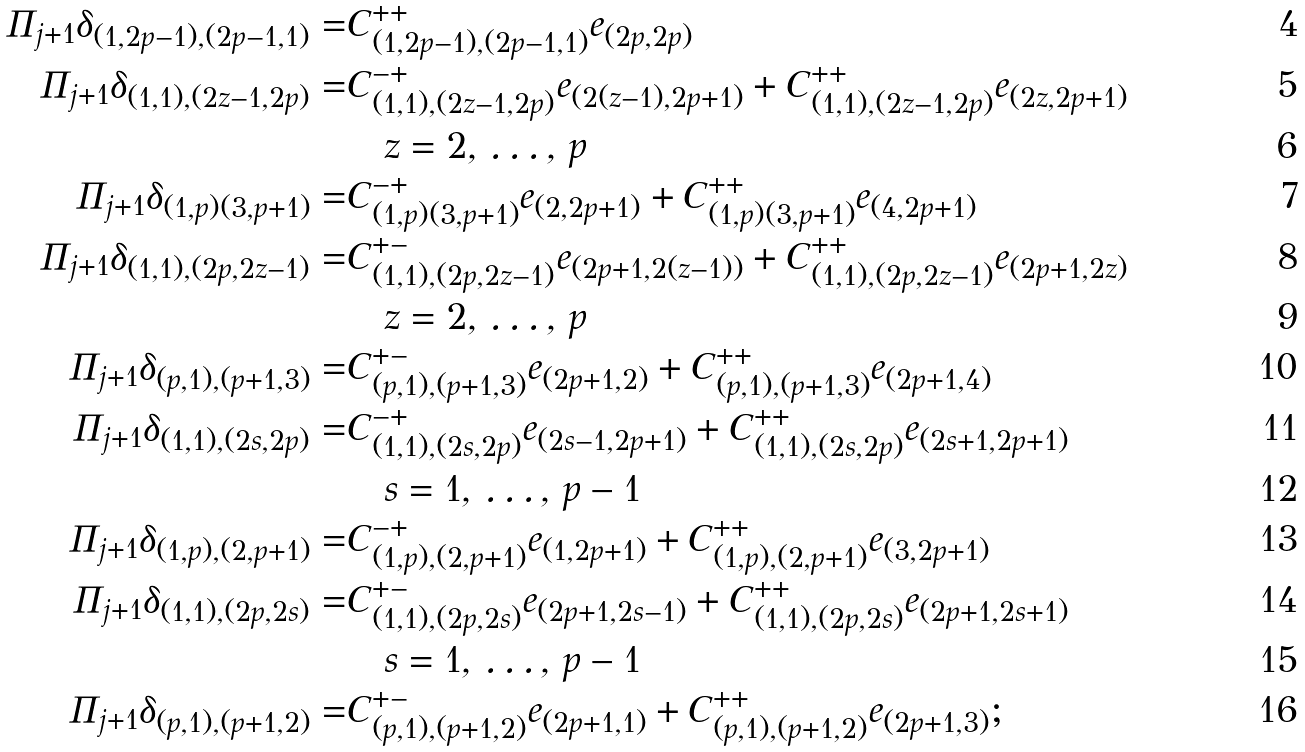<formula> <loc_0><loc_0><loc_500><loc_500>\Pi _ { j + 1 } \delta _ { ( 1 , 2 p - 1 ) , ( 2 p - 1 , 1 ) } = & C _ { ( 1 , 2 p - 1 ) , ( 2 p - 1 , 1 ) } ^ { + + } e _ { ( 2 p , 2 p ) } \\ \Pi _ { j + 1 } \delta _ { ( 1 , 1 ) , ( 2 z - 1 , 2 p ) } = & C _ { ( 1 , 1 ) , ( 2 z - 1 , 2 p ) } ^ { - + } e _ { ( 2 ( z - 1 ) , 2 p + 1 ) } + C _ { ( 1 , 1 ) , ( 2 z - 1 , 2 p ) } ^ { + + } e _ { ( 2 z , 2 p + 1 ) } \\ & \quad z = 2 , \, \dots , \, p \\ \Pi _ { j + 1 } \delta _ { ( 1 , p ) ( 3 , p + 1 ) } = & C _ { ( 1 , p ) ( 3 , p + 1 ) } ^ { - + } e _ { ( 2 , 2 p + 1 ) } + C _ { ( 1 , p ) ( 3 , p + 1 ) } ^ { + + } e _ { ( 4 , 2 p + 1 ) } \\ \Pi _ { j + 1 } \delta _ { ( 1 , 1 ) , ( 2 p , 2 z - 1 ) } = & C _ { ( 1 , 1 ) , ( 2 p , 2 z - 1 ) } ^ { + - } e _ { ( 2 p + 1 , 2 ( z - 1 ) ) } + C _ { ( 1 , 1 ) , ( 2 p , 2 z - 1 ) } ^ { + + } e _ { ( 2 p + 1 , 2 z ) } \\ & \quad z = 2 , \, \dots , \, p \\ \Pi _ { j + 1 } \delta _ { ( p , 1 ) , ( p + 1 , 3 ) } = & C _ { ( p , 1 ) , ( p + 1 , 3 ) } ^ { + - } e _ { ( 2 p + 1 , 2 ) } + C _ { ( p , 1 ) , ( p + 1 , 3 ) } ^ { + + } e _ { ( 2 p + 1 , 4 ) } \\ \Pi _ { j + 1 } \delta _ { ( 1 , 1 ) , ( 2 s , 2 p ) } = & C _ { ( 1 , 1 ) , ( 2 s , 2 p ) } ^ { - + } e _ { ( 2 s - 1 , 2 p + 1 ) } + C _ { ( 1 , 1 ) , ( 2 s , 2 p ) } ^ { + + } e _ { ( 2 s + 1 , 2 p + 1 ) } \\ & \quad s = 1 , \, \dots , \, p - 1 \\ \Pi _ { j + 1 } \delta _ { ( 1 , p ) , ( 2 , p + 1 ) } = & C _ { ( 1 , p ) , ( 2 , p + 1 ) } ^ { - + } e _ { ( 1 , 2 p + 1 ) } + C _ { ( 1 , p ) , ( 2 , p + 1 ) } ^ { + + } e _ { ( 3 , 2 p + 1 ) } \\ \Pi _ { j + 1 } \delta _ { ( 1 , 1 ) , ( 2 p , 2 s ) } = & C _ { ( 1 , 1 ) , ( 2 p , 2 s ) } ^ { + - } e _ { ( 2 p + 1 , 2 s - 1 ) } + C _ { ( 1 , 1 ) , ( 2 p , 2 s ) } ^ { + + } e _ { ( 2 p + 1 , 2 s + 1 ) } \\ & \quad s = 1 , \, \dots , \, p - 1 \\ \Pi _ { j + 1 } \delta _ { ( p , 1 ) , ( p + 1 , 2 ) } = & C _ { ( p , 1 ) , ( p + 1 , 2 ) } ^ { + - } e _ { ( 2 p + 1 , 1 ) } + C _ { ( p , 1 ) , ( p + 1 , 2 ) } ^ { + + } e _ { ( 2 p + 1 , 3 ) } ;</formula> 